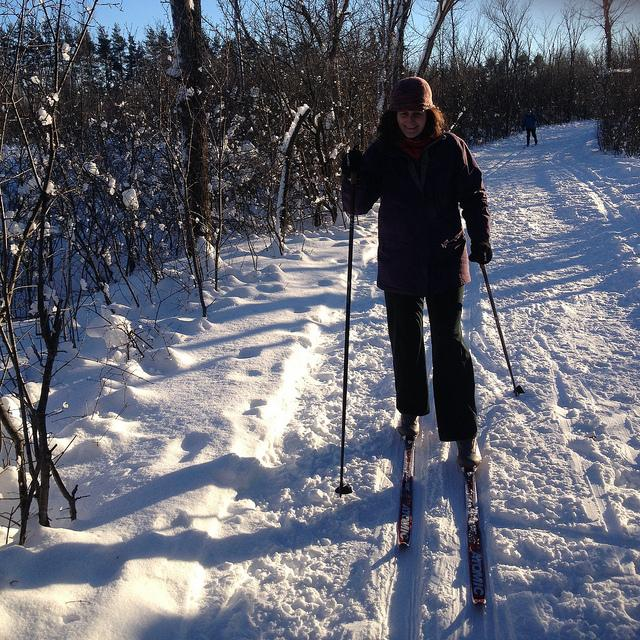What is making the thin lines in the snow? Please explain your reasoning. skis. The skis make the lines. 